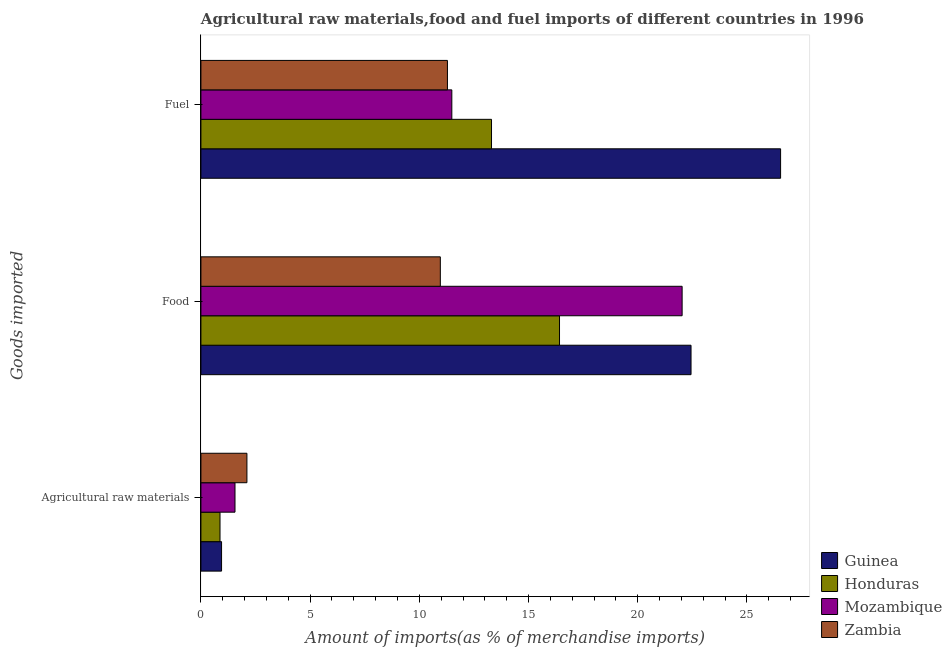How many groups of bars are there?
Give a very brief answer. 3. Are the number of bars per tick equal to the number of legend labels?
Your response must be concise. Yes. Are the number of bars on each tick of the Y-axis equal?
Your answer should be very brief. Yes. What is the label of the 1st group of bars from the top?
Ensure brevity in your answer.  Fuel. What is the percentage of fuel imports in Zambia?
Give a very brief answer. 11.29. Across all countries, what is the maximum percentage of food imports?
Offer a terse response. 22.44. Across all countries, what is the minimum percentage of fuel imports?
Your answer should be compact. 11.29. In which country was the percentage of raw materials imports maximum?
Your answer should be compact. Zambia. In which country was the percentage of raw materials imports minimum?
Offer a very short reply. Honduras. What is the total percentage of food imports in the graph?
Provide a short and direct response. 71.85. What is the difference between the percentage of food imports in Guinea and that in Mozambique?
Offer a terse response. 0.41. What is the difference between the percentage of raw materials imports in Mozambique and the percentage of food imports in Honduras?
Your response must be concise. -14.86. What is the average percentage of raw materials imports per country?
Your answer should be very brief. 1.37. What is the difference between the percentage of fuel imports and percentage of food imports in Mozambique?
Offer a terse response. -10.54. What is the ratio of the percentage of fuel imports in Guinea to that in Zambia?
Ensure brevity in your answer.  2.35. Is the difference between the percentage of food imports in Guinea and Mozambique greater than the difference between the percentage of raw materials imports in Guinea and Mozambique?
Your answer should be very brief. Yes. What is the difference between the highest and the second highest percentage of fuel imports?
Make the answer very short. 13.24. What is the difference between the highest and the lowest percentage of food imports?
Offer a terse response. 11.48. In how many countries, is the percentage of food imports greater than the average percentage of food imports taken over all countries?
Give a very brief answer. 2. Is the sum of the percentage of food imports in Honduras and Mozambique greater than the maximum percentage of raw materials imports across all countries?
Provide a succinct answer. Yes. What does the 3rd bar from the top in Agricultural raw materials represents?
Keep it short and to the point. Honduras. What does the 1st bar from the bottom in Food represents?
Offer a terse response. Guinea. Is it the case that in every country, the sum of the percentage of raw materials imports and percentage of food imports is greater than the percentage of fuel imports?
Make the answer very short. No. Are the values on the major ticks of X-axis written in scientific E-notation?
Provide a succinct answer. No. Does the graph contain any zero values?
Ensure brevity in your answer.  No. Does the graph contain grids?
Make the answer very short. No. What is the title of the graph?
Keep it short and to the point. Agricultural raw materials,food and fuel imports of different countries in 1996. What is the label or title of the X-axis?
Provide a succinct answer. Amount of imports(as % of merchandise imports). What is the label or title of the Y-axis?
Your answer should be very brief. Goods imported. What is the Amount of imports(as % of merchandise imports) in Guinea in Agricultural raw materials?
Ensure brevity in your answer.  0.95. What is the Amount of imports(as % of merchandise imports) in Honduras in Agricultural raw materials?
Your response must be concise. 0.87. What is the Amount of imports(as % of merchandise imports) of Mozambique in Agricultural raw materials?
Your answer should be compact. 1.56. What is the Amount of imports(as % of merchandise imports) of Zambia in Agricultural raw materials?
Give a very brief answer. 2.11. What is the Amount of imports(as % of merchandise imports) in Guinea in Food?
Give a very brief answer. 22.44. What is the Amount of imports(as % of merchandise imports) of Honduras in Food?
Give a very brief answer. 16.42. What is the Amount of imports(as % of merchandise imports) in Mozambique in Food?
Offer a very short reply. 22.03. What is the Amount of imports(as % of merchandise imports) of Zambia in Food?
Provide a short and direct response. 10.96. What is the Amount of imports(as % of merchandise imports) of Guinea in Fuel?
Ensure brevity in your answer.  26.54. What is the Amount of imports(as % of merchandise imports) of Honduras in Fuel?
Offer a terse response. 13.31. What is the Amount of imports(as % of merchandise imports) of Mozambique in Fuel?
Make the answer very short. 11.49. What is the Amount of imports(as % of merchandise imports) of Zambia in Fuel?
Make the answer very short. 11.29. Across all Goods imported, what is the maximum Amount of imports(as % of merchandise imports) in Guinea?
Ensure brevity in your answer.  26.54. Across all Goods imported, what is the maximum Amount of imports(as % of merchandise imports) of Honduras?
Your answer should be compact. 16.42. Across all Goods imported, what is the maximum Amount of imports(as % of merchandise imports) of Mozambique?
Offer a very short reply. 22.03. Across all Goods imported, what is the maximum Amount of imports(as % of merchandise imports) in Zambia?
Offer a very short reply. 11.29. Across all Goods imported, what is the minimum Amount of imports(as % of merchandise imports) of Guinea?
Ensure brevity in your answer.  0.95. Across all Goods imported, what is the minimum Amount of imports(as % of merchandise imports) in Honduras?
Keep it short and to the point. 0.87. Across all Goods imported, what is the minimum Amount of imports(as % of merchandise imports) of Mozambique?
Your response must be concise. 1.56. Across all Goods imported, what is the minimum Amount of imports(as % of merchandise imports) in Zambia?
Offer a terse response. 2.11. What is the total Amount of imports(as % of merchandise imports) in Guinea in the graph?
Provide a short and direct response. 49.93. What is the total Amount of imports(as % of merchandise imports) in Honduras in the graph?
Your answer should be compact. 30.6. What is the total Amount of imports(as % of merchandise imports) of Mozambique in the graph?
Your response must be concise. 35.08. What is the total Amount of imports(as % of merchandise imports) of Zambia in the graph?
Make the answer very short. 24.36. What is the difference between the Amount of imports(as % of merchandise imports) of Guinea in Agricultural raw materials and that in Food?
Ensure brevity in your answer.  -21.5. What is the difference between the Amount of imports(as % of merchandise imports) of Honduras in Agricultural raw materials and that in Food?
Provide a succinct answer. -15.54. What is the difference between the Amount of imports(as % of merchandise imports) in Mozambique in Agricultural raw materials and that in Food?
Your answer should be very brief. -20.47. What is the difference between the Amount of imports(as % of merchandise imports) of Zambia in Agricultural raw materials and that in Food?
Ensure brevity in your answer.  -8.86. What is the difference between the Amount of imports(as % of merchandise imports) of Guinea in Agricultural raw materials and that in Fuel?
Your answer should be compact. -25.6. What is the difference between the Amount of imports(as % of merchandise imports) in Honduras in Agricultural raw materials and that in Fuel?
Keep it short and to the point. -12.43. What is the difference between the Amount of imports(as % of merchandise imports) in Mozambique in Agricultural raw materials and that in Fuel?
Provide a succinct answer. -9.93. What is the difference between the Amount of imports(as % of merchandise imports) in Zambia in Agricultural raw materials and that in Fuel?
Your answer should be very brief. -9.18. What is the difference between the Amount of imports(as % of merchandise imports) of Guinea in Food and that in Fuel?
Offer a terse response. -4.1. What is the difference between the Amount of imports(as % of merchandise imports) in Honduras in Food and that in Fuel?
Ensure brevity in your answer.  3.11. What is the difference between the Amount of imports(as % of merchandise imports) in Mozambique in Food and that in Fuel?
Give a very brief answer. 10.54. What is the difference between the Amount of imports(as % of merchandise imports) in Zambia in Food and that in Fuel?
Give a very brief answer. -0.33. What is the difference between the Amount of imports(as % of merchandise imports) of Guinea in Agricultural raw materials and the Amount of imports(as % of merchandise imports) of Honduras in Food?
Offer a very short reply. -15.47. What is the difference between the Amount of imports(as % of merchandise imports) of Guinea in Agricultural raw materials and the Amount of imports(as % of merchandise imports) of Mozambique in Food?
Ensure brevity in your answer.  -21.09. What is the difference between the Amount of imports(as % of merchandise imports) in Guinea in Agricultural raw materials and the Amount of imports(as % of merchandise imports) in Zambia in Food?
Make the answer very short. -10.02. What is the difference between the Amount of imports(as % of merchandise imports) in Honduras in Agricultural raw materials and the Amount of imports(as % of merchandise imports) in Mozambique in Food?
Keep it short and to the point. -21.16. What is the difference between the Amount of imports(as % of merchandise imports) of Honduras in Agricultural raw materials and the Amount of imports(as % of merchandise imports) of Zambia in Food?
Your answer should be compact. -10.09. What is the difference between the Amount of imports(as % of merchandise imports) in Mozambique in Agricultural raw materials and the Amount of imports(as % of merchandise imports) in Zambia in Food?
Your answer should be compact. -9.4. What is the difference between the Amount of imports(as % of merchandise imports) in Guinea in Agricultural raw materials and the Amount of imports(as % of merchandise imports) in Honduras in Fuel?
Provide a short and direct response. -12.36. What is the difference between the Amount of imports(as % of merchandise imports) in Guinea in Agricultural raw materials and the Amount of imports(as % of merchandise imports) in Mozambique in Fuel?
Your response must be concise. -10.54. What is the difference between the Amount of imports(as % of merchandise imports) of Guinea in Agricultural raw materials and the Amount of imports(as % of merchandise imports) of Zambia in Fuel?
Offer a terse response. -10.34. What is the difference between the Amount of imports(as % of merchandise imports) in Honduras in Agricultural raw materials and the Amount of imports(as % of merchandise imports) in Mozambique in Fuel?
Provide a succinct answer. -10.61. What is the difference between the Amount of imports(as % of merchandise imports) in Honduras in Agricultural raw materials and the Amount of imports(as % of merchandise imports) in Zambia in Fuel?
Provide a short and direct response. -10.41. What is the difference between the Amount of imports(as % of merchandise imports) of Mozambique in Agricultural raw materials and the Amount of imports(as % of merchandise imports) of Zambia in Fuel?
Your answer should be very brief. -9.73. What is the difference between the Amount of imports(as % of merchandise imports) of Guinea in Food and the Amount of imports(as % of merchandise imports) of Honduras in Fuel?
Offer a terse response. 9.13. What is the difference between the Amount of imports(as % of merchandise imports) in Guinea in Food and the Amount of imports(as % of merchandise imports) in Mozambique in Fuel?
Make the answer very short. 10.95. What is the difference between the Amount of imports(as % of merchandise imports) of Guinea in Food and the Amount of imports(as % of merchandise imports) of Zambia in Fuel?
Your response must be concise. 11.15. What is the difference between the Amount of imports(as % of merchandise imports) in Honduras in Food and the Amount of imports(as % of merchandise imports) in Mozambique in Fuel?
Provide a short and direct response. 4.93. What is the difference between the Amount of imports(as % of merchandise imports) of Honduras in Food and the Amount of imports(as % of merchandise imports) of Zambia in Fuel?
Make the answer very short. 5.13. What is the difference between the Amount of imports(as % of merchandise imports) of Mozambique in Food and the Amount of imports(as % of merchandise imports) of Zambia in Fuel?
Your answer should be very brief. 10.75. What is the average Amount of imports(as % of merchandise imports) in Guinea per Goods imported?
Your answer should be very brief. 16.64. What is the average Amount of imports(as % of merchandise imports) in Honduras per Goods imported?
Offer a very short reply. 10.2. What is the average Amount of imports(as % of merchandise imports) of Mozambique per Goods imported?
Offer a terse response. 11.69. What is the average Amount of imports(as % of merchandise imports) in Zambia per Goods imported?
Your answer should be compact. 8.12. What is the difference between the Amount of imports(as % of merchandise imports) of Guinea and Amount of imports(as % of merchandise imports) of Honduras in Agricultural raw materials?
Make the answer very short. 0.07. What is the difference between the Amount of imports(as % of merchandise imports) of Guinea and Amount of imports(as % of merchandise imports) of Mozambique in Agricultural raw materials?
Make the answer very short. -0.61. What is the difference between the Amount of imports(as % of merchandise imports) in Guinea and Amount of imports(as % of merchandise imports) in Zambia in Agricultural raw materials?
Your response must be concise. -1.16. What is the difference between the Amount of imports(as % of merchandise imports) in Honduras and Amount of imports(as % of merchandise imports) in Mozambique in Agricultural raw materials?
Provide a succinct answer. -0.69. What is the difference between the Amount of imports(as % of merchandise imports) in Honduras and Amount of imports(as % of merchandise imports) in Zambia in Agricultural raw materials?
Offer a terse response. -1.23. What is the difference between the Amount of imports(as % of merchandise imports) in Mozambique and Amount of imports(as % of merchandise imports) in Zambia in Agricultural raw materials?
Provide a succinct answer. -0.55. What is the difference between the Amount of imports(as % of merchandise imports) of Guinea and Amount of imports(as % of merchandise imports) of Honduras in Food?
Ensure brevity in your answer.  6.02. What is the difference between the Amount of imports(as % of merchandise imports) of Guinea and Amount of imports(as % of merchandise imports) of Mozambique in Food?
Your answer should be compact. 0.41. What is the difference between the Amount of imports(as % of merchandise imports) of Guinea and Amount of imports(as % of merchandise imports) of Zambia in Food?
Your answer should be very brief. 11.48. What is the difference between the Amount of imports(as % of merchandise imports) in Honduras and Amount of imports(as % of merchandise imports) in Mozambique in Food?
Ensure brevity in your answer.  -5.61. What is the difference between the Amount of imports(as % of merchandise imports) of Honduras and Amount of imports(as % of merchandise imports) of Zambia in Food?
Offer a very short reply. 5.46. What is the difference between the Amount of imports(as % of merchandise imports) in Mozambique and Amount of imports(as % of merchandise imports) in Zambia in Food?
Give a very brief answer. 11.07. What is the difference between the Amount of imports(as % of merchandise imports) of Guinea and Amount of imports(as % of merchandise imports) of Honduras in Fuel?
Keep it short and to the point. 13.24. What is the difference between the Amount of imports(as % of merchandise imports) of Guinea and Amount of imports(as % of merchandise imports) of Mozambique in Fuel?
Provide a succinct answer. 15.05. What is the difference between the Amount of imports(as % of merchandise imports) of Guinea and Amount of imports(as % of merchandise imports) of Zambia in Fuel?
Keep it short and to the point. 15.25. What is the difference between the Amount of imports(as % of merchandise imports) of Honduras and Amount of imports(as % of merchandise imports) of Mozambique in Fuel?
Give a very brief answer. 1.82. What is the difference between the Amount of imports(as % of merchandise imports) of Honduras and Amount of imports(as % of merchandise imports) of Zambia in Fuel?
Provide a short and direct response. 2.02. What is the difference between the Amount of imports(as % of merchandise imports) in Mozambique and Amount of imports(as % of merchandise imports) in Zambia in Fuel?
Provide a succinct answer. 0.2. What is the ratio of the Amount of imports(as % of merchandise imports) of Guinea in Agricultural raw materials to that in Food?
Make the answer very short. 0.04. What is the ratio of the Amount of imports(as % of merchandise imports) in Honduras in Agricultural raw materials to that in Food?
Keep it short and to the point. 0.05. What is the ratio of the Amount of imports(as % of merchandise imports) in Mozambique in Agricultural raw materials to that in Food?
Your response must be concise. 0.07. What is the ratio of the Amount of imports(as % of merchandise imports) of Zambia in Agricultural raw materials to that in Food?
Provide a short and direct response. 0.19. What is the ratio of the Amount of imports(as % of merchandise imports) in Guinea in Agricultural raw materials to that in Fuel?
Provide a short and direct response. 0.04. What is the ratio of the Amount of imports(as % of merchandise imports) in Honduras in Agricultural raw materials to that in Fuel?
Keep it short and to the point. 0.07. What is the ratio of the Amount of imports(as % of merchandise imports) of Mozambique in Agricultural raw materials to that in Fuel?
Your answer should be very brief. 0.14. What is the ratio of the Amount of imports(as % of merchandise imports) of Zambia in Agricultural raw materials to that in Fuel?
Provide a succinct answer. 0.19. What is the ratio of the Amount of imports(as % of merchandise imports) in Guinea in Food to that in Fuel?
Your answer should be compact. 0.85. What is the ratio of the Amount of imports(as % of merchandise imports) of Honduras in Food to that in Fuel?
Offer a terse response. 1.23. What is the ratio of the Amount of imports(as % of merchandise imports) of Mozambique in Food to that in Fuel?
Ensure brevity in your answer.  1.92. What is the ratio of the Amount of imports(as % of merchandise imports) of Zambia in Food to that in Fuel?
Offer a terse response. 0.97. What is the difference between the highest and the second highest Amount of imports(as % of merchandise imports) of Guinea?
Provide a succinct answer. 4.1. What is the difference between the highest and the second highest Amount of imports(as % of merchandise imports) in Honduras?
Give a very brief answer. 3.11. What is the difference between the highest and the second highest Amount of imports(as % of merchandise imports) of Mozambique?
Offer a terse response. 10.54. What is the difference between the highest and the second highest Amount of imports(as % of merchandise imports) of Zambia?
Offer a terse response. 0.33. What is the difference between the highest and the lowest Amount of imports(as % of merchandise imports) in Guinea?
Ensure brevity in your answer.  25.6. What is the difference between the highest and the lowest Amount of imports(as % of merchandise imports) in Honduras?
Provide a short and direct response. 15.54. What is the difference between the highest and the lowest Amount of imports(as % of merchandise imports) of Mozambique?
Your answer should be very brief. 20.47. What is the difference between the highest and the lowest Amount of imports(as % of merchandise imports) of Zambia?
Provide a short and direct response. 9.18. 